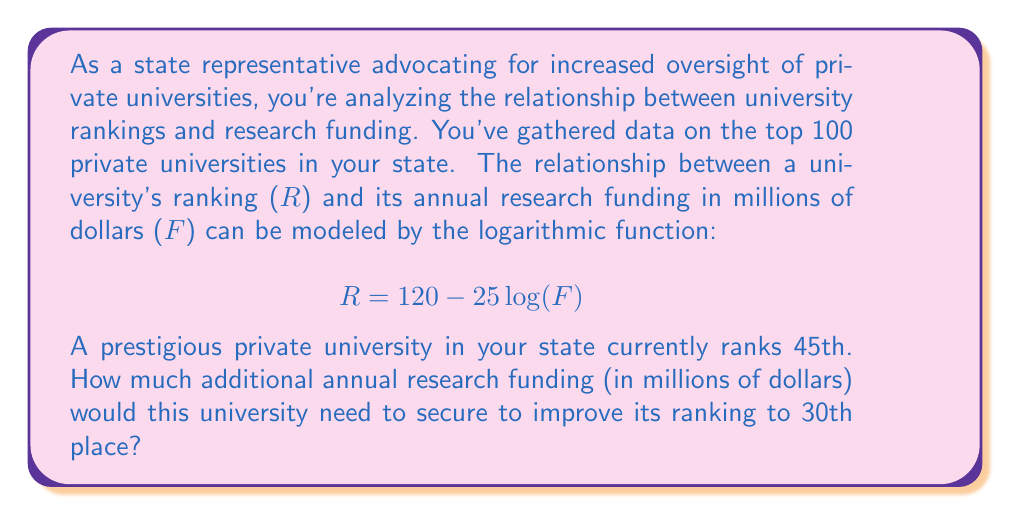What is the answer to this math problem? To solve this problem, we'll use the given logarithmic function and follow these steps:

1) First, let's write out the equations for the current and desired rankings:
   Current ranking: $45 = 120 - 25\log(F_1)$
   Desired ranking: $30 = 120 - 25\log(F_2)$

   Where $F_1$ is the current funding and $F_2$ is the desired funding.

2) Solve for $\log(F_1)$ in the first equation:
   $45 = 120 - 25\log(F_1)$
   $25\log(F_1) = 120 - 45 = 75$
   $\log(F_1) = 3$

3) Solve for $\log(F_2)$ in the second equation:
   $30 = 120 - 25\log(F_2)$
   $25\log(F_2) = 120 - 30 = 90$
   $\log(F_2) = 3.6$

4) Now, we can find $F_1$ and $F_2$:
   $F_1 = 10^3 = 1000$ million dollars
   $F_2 = 10^{3.6} \approx 3981.07$ million dollars

5) The additional funding needed is the difference between $F_2$ and $F_1$:
   Additional funding $= F_2 - F_1 \approx 3981.07 - 1000 = 2981.07$ million dollars
Answer: The university would need to secure approximately $2981.07 million (or about $2.98 billion) in additional annual research funding to improve its ranking from 45th to 30th place. 